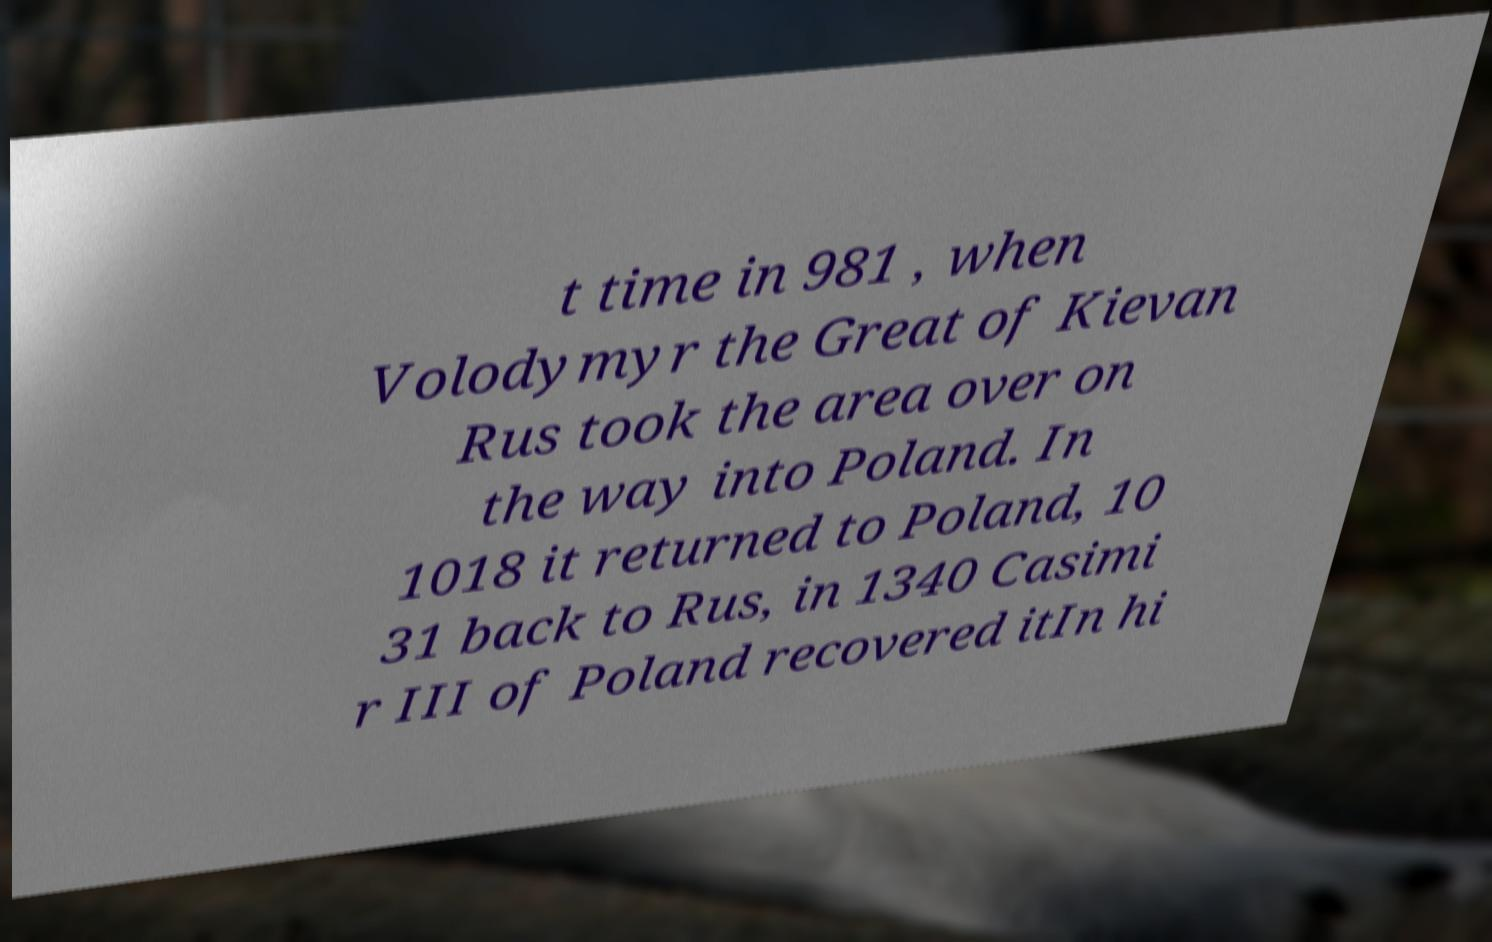Please read and relay the text visible in this image. What does it say? t time in 981 , when Volodymyr the Great of Kievan Rus took the area over on the way into Poland. In 1018 it returned to Poland, 10 31 back to Rus, in 1340 Casimi r III of Poland recovered itIn hi 